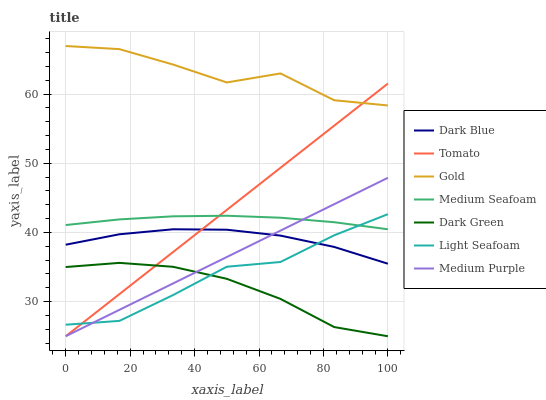Does Dark Green have the minimum area under the curve?
Answer yes or no. Yes. Does Gold have the maximum area under the curve?
Answer yes or no. Yes. Does Medium Purple have the minimum area under the curve?
Answer yes or no. No. Does Medium Purple have the maximum area under the curve?
Answer yes or no. No. Is Tomato the smoothest?
Answer yes or no. Yes. Is Gold the roughest?
Answer yes or no. Yes. Is Medium Purple the smoothest?
Answer yes or no. No. Is Medium Purple the roughest?
Answer yes or no. No. Does Tomato have the lowest value?
Answer yes or no. Yes. Does Gold have the lowest value?
Answer yes or no. No. Does Gold have the highest value?
Answer yes or no. Yes. Does Medium Purple have the highest value?
Answer yes or no. No. Is Medium Purple less than Gold?
Answer yes or no. Yes. Is Gold greater than Medium Seafoam?
Answer yes or no. Yes. Does Medium Purple intersect Light Seafoam?
Answer yes or no. Yes. Is Medium Purple less than Light Seafoam?
Answer yes or no. No. Is Medium Purple greater than Light Seafoam?
Answer yes or no. No. Does Medium Purple intersect Gold?
Answer yes or no. No. 